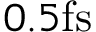Convert formula to latex. <formula><loc_0><loc_0><loc_500><loc_500>0 . 5 f s</formula> 